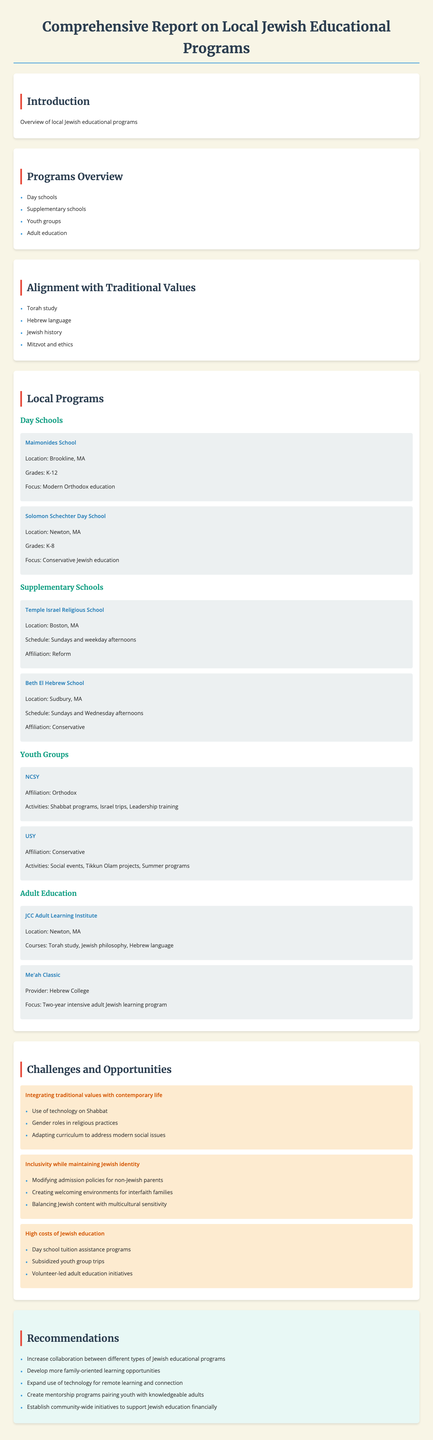What types of educational programs are covered in the report? The report outlines various local educational programs including day schools, supplementary schools, youth groups, and adult education.
Answer: Day schools, supplementary schools, youth groups, adult education Which school focuses on Modern Orthodox education? The document mentions Maimonides School as the one focusing on Modern Orthodox education.
Answer: Maimonides School What is the primary focus of the JCC Adult Learning Institute? The primary focus of the JCC Adult Learning Institute is on courses such as Torah study, Jewish philosophy, and Hebrew language.
Answer: Torah study, Jewish philosophy, Hebrew language What challenge involves integrating traditional values with contemporary life? The challenge that deals with this issue is termed "balancing tradition and modernity."
Answer: Balancing tradition and modernity How many recommendations are provided in the report? The report includes a total of five recommendations for strengthening Jewish education.
Answer: Five What Jewish value is emphasized through regular Torah reading and discussion in day schools? Regular Torah reading and discussion in day schools emphasizes the value of Torah study.
Answer: Torah study What is a common activity for NCSY youth group? One of the common activities for the NCSY youth group is Shabbat programs.
Answer: Shabbat programs Which supplementary school is affiliated with Reform Judaism? Temple Israel Religious School is affiliated with Reform Judaism.
Answer: Temple Israel Religious School 